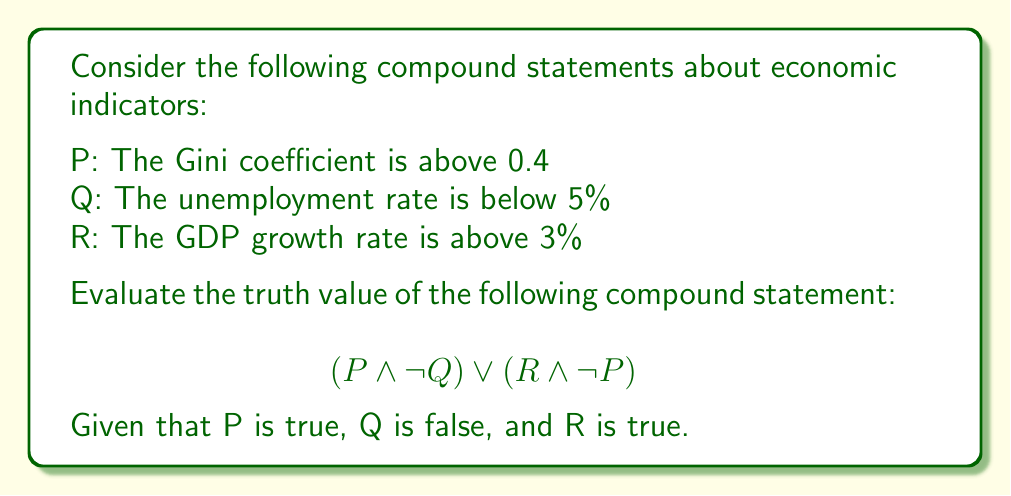Give your solution to this math problem. Let's break this down step-by-step:

1) We are given the following truth values:
   P: True
   Q: False
   R: True

2) Let's evaluate each part of the compound statement:

   a) $(P \land \neg Q)$:
      - P is true
      - $\neg Q$ is the negation of Q. Since Q is false, $\neg Q$ is true
      - True $\land$ True = True

   b) $(R \land \neg P)$:
      - R is true
      - $\neg P$ is the negation of P. Since P is true, $\neg P$ is false
      - True $\land$ False = False

3) Now we have:
   $(P \land \neg Q) \lor (R \land \neg P)$
   = True $\lor$ False

4) In Boolean logic, the $\lor$ (OR) operator returns true if at least one of its operands is true.

5) Since True $\lor$ False = True, the entire compound statement is true.

This analysis demonstrates how different economic indicators can be combined logically to create more complex statements about the economy, which can be useful in policy-making decisions.
Answer: True 